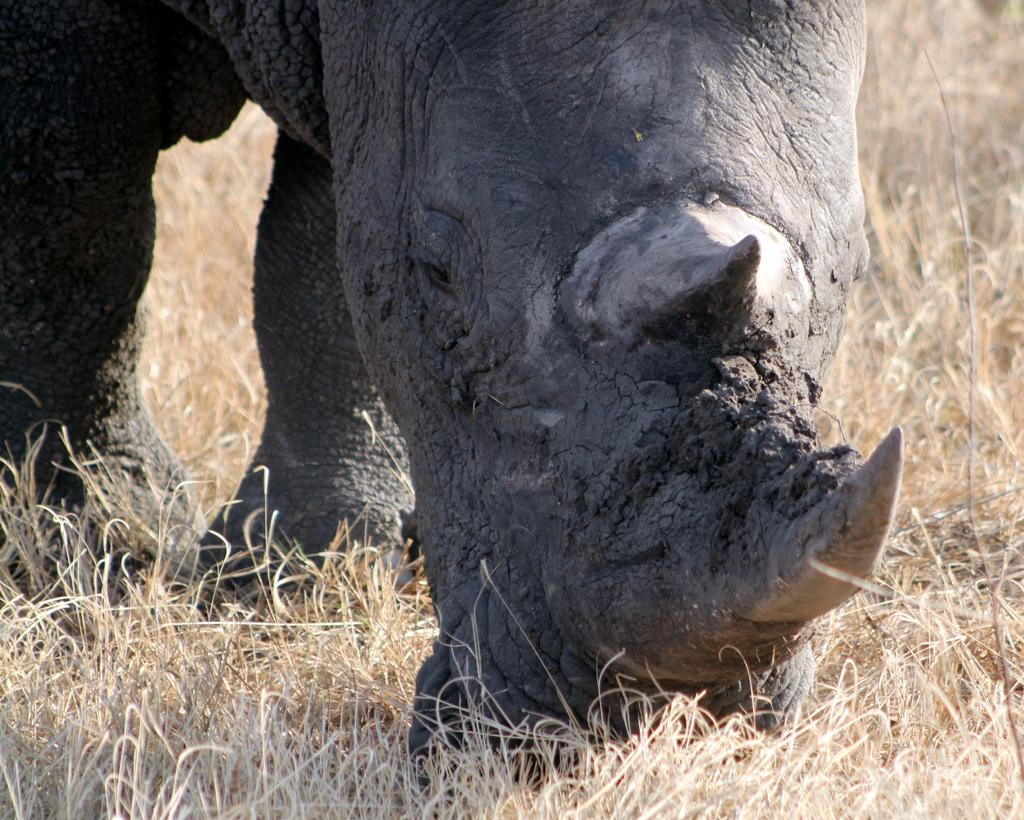What animal is present in the image? There is a rhinoceros in the image. Where is the rhinoceros located in the image? The rhinoceros is on the ground. What type of vegetation can be seen in the image? There is dried grass visible in the image. What type of government is depicted in the image? There is no depiction of a government in the image; it features a rhinoceros on the ground with dried grass. Can you tell me how many police officers are present in the image? There are no police officers present in the image; it features a rhinoceros on the ground with dried grass. 